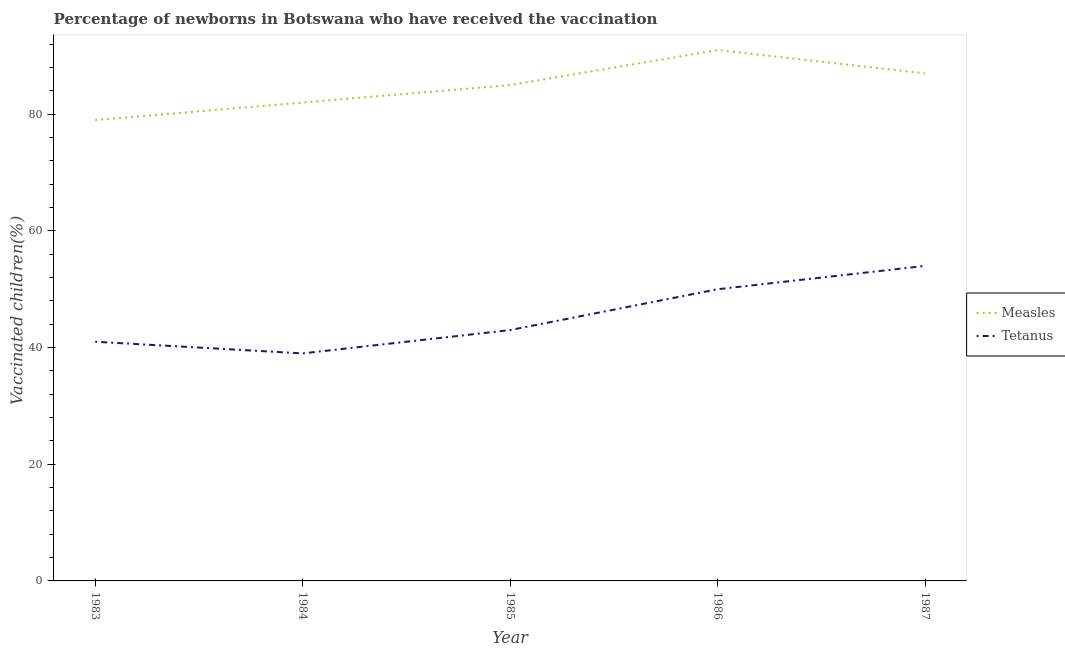How many different coloured lines are there?
Give a very brief answer. 2. Does the line corresponding to percentage of newborns who received vaccination for tetanus intersect with the line corresponding to percentage of newborns who received vaccination for measles?
Make the answer very short. No. Is the number of lines equal to the number of legend labels?
Your response must be concise. Yes. What is the percentage of newborns who received vaccination for measles in 1983?
Give a very brief answer. 79. Across all years, what is the maximum percentage of newborns who received vaccination for measles?
Give a very brief answer. 91. Across all years, what is the minimum percentage of newborns who received vaccination for tetanus?
Ensure brevity in your answer.  39. What is the total percentage of newborns who received vaccination for measles in the graph?
Your answer should be very brief. 424. What is the difference between the percentage of newborns who received vaccination for measles in 1983 and that in 1986?
Your answer should be very brief. -12. What is the difference between the percentage of newborns who received vaccination for tetanus in 1986 and the percentage of newborns who received vaccination for measles in 1983?
Your answer should be very brief. -29. What is the average percentage of newborns who received vaccination for tetanus per year?
Ensure brevity in your answer.  45.4. In the year 1986, what is the difference between the percentage of newborns who received vaccination for measles and percentage of newborns who received vaccination for tetanus?
Offer a very short reply. 41. In how many years, is the percentage of newborns who received vaccination for measles greater than 84 %?
Provide a succinct answer. 3. What is the ratio of the percentage of newborns who received vaccination for tetanus in 1985 to that in 1987?
Your answer should be compact. 0.8. What is the difference between the highest and the second highest percentage of newborns who received vaccination for tetanus?
Your response must be concise. 4. What is the difference between the highest and the lowest percentage of newborns who received vaccination for measles?
Offer a terse response. 12. Is the percentage of newborns who received vaccination for tetanus strictly less than the percentage of newborns who received vaccination for measles over the years?
Offer a very short reply. Yes. How many years are there in the graph?
Keep it short and to the point. 5. What is the difference between two consecutive major ticks on the Y-axis?
Give a very brief answer. 20. Are the values on the major ticks of Y-axis written in scientific E-notation?
Your answer should be compact. No. Does the graph contain grids?
Your answer should be very brief. No. Where does the legend appear in the graph?
Provide a succinct answer. Center right. How are the legend labels stacked?
Make the answer very short. Vertical. What is the title of the graph?
Offer a terse response. Percentage of newborns in Botswana who have received the vaccination. What is the label or title of the Y-axis?
Ensure brevity in your answer.  Vaccinated children(%)
. What is the Vaccinated children(%)
 in Measles in 1983?
Offer a very short reply. 79. What is the Vaccinated children(%)
 in Tetanus in 1984?
Offer a terse response. 39. What is the Vaccinated children(%)
 in Measles in 1986?
Keep it short and to the point. 91. What is the Vaccinated children(%)
 of Tetanus in 1986?
Make the answer very short. 50. What is the Vaccinated children(%)
 of Tetanus in 1987?
Give a very brief answer. 54. Across all years, what is the maximum Vaccinated children(%)
 in Measles?
Your answer should be very brief. 91. Across all years, what is the minimum Vaccinated children(%)
 of Measles?
Your answer should be compact. 79. Across all years, what is the minimum Vaccinated children(%)
 of Tetanus?
Offer a terse response. 39. What is the total Vaccinated children(%)
 in Measles in the graph?
Provide a succinct answer. 424. What is the total Vaccinated children(%)
 in Tetanus in the graph?
Your answer should be very brief. 227. What is the difference between the Vaccinated children(%)
 in Measles in 1983 and that in 1984?
Provide a succinct answer. -3. What is the difference between the Vaccinated children(%)
 in Measles in 1983 and that in 1985?
Keep it short and to the point. -6. What is the difference between the Vaccinated children(%)
 of Tetanus in 1984 and that in 1985?
Your answer should be compact. -4. What is the difference between the Vaccinated children(%)
 in Measles in 1984 and that in 1986?
Give a very brief answer. -9. What is the difference between the Vaccinated children(%)
 in Tetanus in 1984 and that in 1986?
Make the answer very short. -11. What is the difference between the Vaccinated children(%)
 in Tetanus in 1985 and that in 1986?
Provide a succinct answer. -7. What is the difference between the Vaccinated children(%)
 of Tetanus in 1985 and that in 1987?
Make the answer very short. -11. What is the difference between the Vaccinated children(%)
 in Measles in 1986 and that in 1987?
Your answer should be very brief. 4. What is the difference between the Vaccinated children(%)
 of Measles in 1983 and the Vaccinated children(%)
 of Tetanus in 1984?
Make the answer very short. 40. What is the difference between the Vaccinated children(%)
 of Measles in 1983 and the Vaccinated children(%)
 of Tetanus in 1987?
Offer a terse response. 25. What is the difference between the Vaccinated children(%)
 in Measles in 1984 and the Vaccinated children(%)
 in Tetanus in 1986?
Your answer should be very brief. 32. What is the difference between the Vaccinated children(%)
 in Measles in 1985 and the Vaccinated children(%)
 in Tetanus in 1986?
Make the answer very short. 35. What is the difference between the Vaccinated children(%)
 in Measles in 1985 and the Vaccinated children(%)
 in Tetanus in 1987?
Keep it short and to the point. 31. What is the difference between the Vaccinated children(%)
 in Measles in 1986 and the Vaccinated children(%)
 in Tetanus in 1987?
Make the answer very short. 37. What is the average Vaccinated children(%)
 in Measles per year?
Offer a terse response. 84.8. What is the average Vaccinated children(%)
 of Tetanus per year?
Ensure brevity in your answer.  45.4. In the year 1983, what is the difference between the Vaccinated children(%)
 in Measles and Vaccinated children(%)
 in Tetanus?
Provide a succinct answer. 38. What is the ratio of the Vaccinated children(%)
 of Measles in 1983 to that in 1984?
Your response must be concise. 0.96. What is the ratio of the Vaccinated children(%)
 in Tetanus in 1983 to that in 1984?
Offer a terse response. 1.05. What is the ratio of the Vaccinated children(%)
 of Measles in 1983 to that in 1985?
Give a very brief answer. 0.93. What is the ratio of the Vaccinated children(%)
 of Tetanus in 1983 to that in 1985?
Provide a succinct answer. 0.95. What is the ratio of the Vaccinated children(%)
 of Measles in 1983 to that in 1986?
Offer a terse response. 0.87. What is the ratio of the Vaccinated children(%)
 in Tetanus in 1983 to that in 1986?
Keep it short and to the point. 0.82. What is the ratio of the Vaccinated children(%)
 of Measles in 1983 to that in 1987?
Make the answer very short. 0.91. What is the ratio of the Vaccinated children(%)
 in Tetanus in 1983 to that in 1987?
Offer a terse response. 0.76. What is the ratio of the Vaccinated children(%)
 of Measles in 1984 to that in 1985?
Provide a short and direct response. 0.96. What is the ratio of the Vaccinated children(%)
 of Tetanus in 1984 to that in 1985?
Your response must be concise. 0.91. What is the ratio of the Vaccinated children(%)
 in Measles in 1984 to that in 1986?
Your answer should be compact. 0.9. What is the ratio of the Vaccinated children(%)
 of Tetanus in 1984 to that in 1986?
Your answer should be compact. 0.78. What is the ratio of the Vaccinated children(%)
 of Measles in 1984 to that in 1987?
Offer a very short reply. 0.94. What is the ratio of the Vaccinated children(%)
 in Tetanus in 1984 to that in 1987?
Give a very brief answer. 0.72. What is the ratio of the Vaccinated children(%)
 of Measles in 1985 to that in 1986?
Make the answer very short. 0.93. What is the ratio of the Vaccinated children(%)
 of Tetanus in 1985 to that in 1986?
Provide a short and direct response. 0.86. What is the ratio of the Vaccinated children(%)
 in Measles in 1985 to that in 1987?
Give a very brief answer. 0.98. What is the ratio of the Vaccinated children(%)
 of Tetanus in 1985 to that in 1987?
Ensure brevity in your answer.  0.8. What is the ratio of the Vaccinated children(%)
 in Measles in 1986 to that in 1987?
Provide a succinct answer. 1.05. What is the ratio of the Vaccinated children(%)
 of Tetanus in 1986 to that in 1987?
Your answer should be compact. 0.93. What is the difference between the highest and the lowest Vaccinated children(%)
 in Measles?
Give a very brief answer. 12. What is the difference between the highest and the lowest Vaccinated children(%)
 in Tetanus?
Keep it short and to the point. 15. 